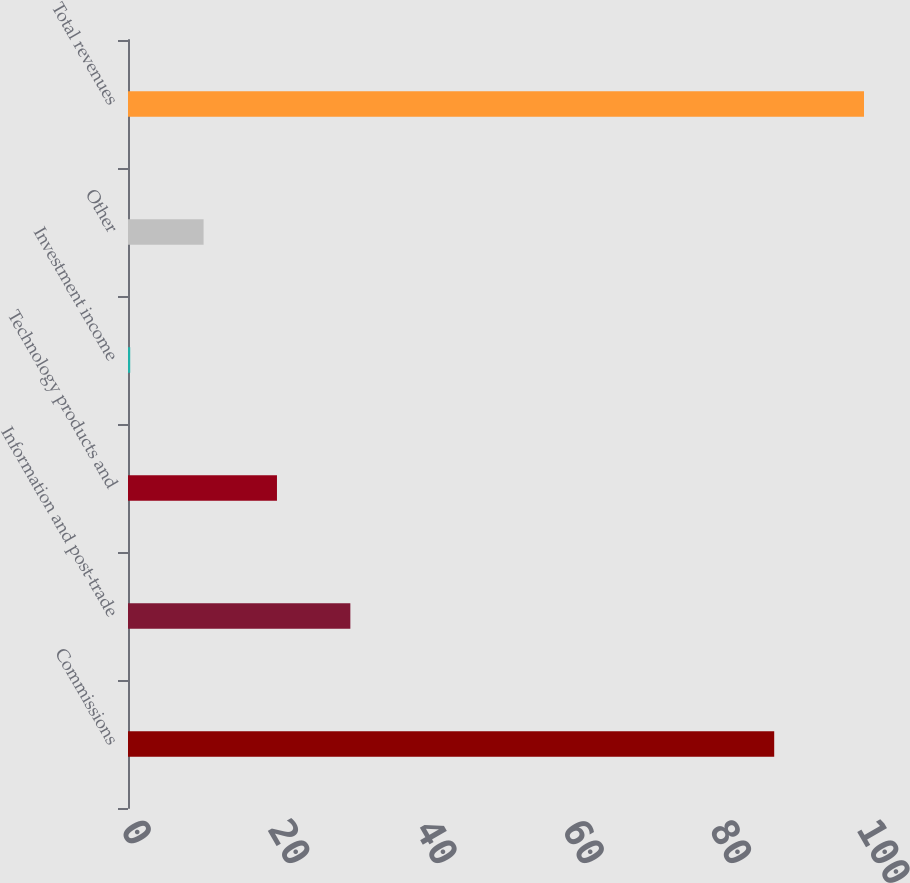<chart> <loc_0><loc_0><loc_500><loc_500><bar_chart><fcel>Commissions<fcel>Information and post-trade<fcel>Technology products and<fcel>Investment income<fcel>Other<fcel>Total revenues<nl><fcel>87.8<fcel>30.21<fcel>20.24<fcel>0.3<fcel>10.27<fcel>100<nl></chart> 